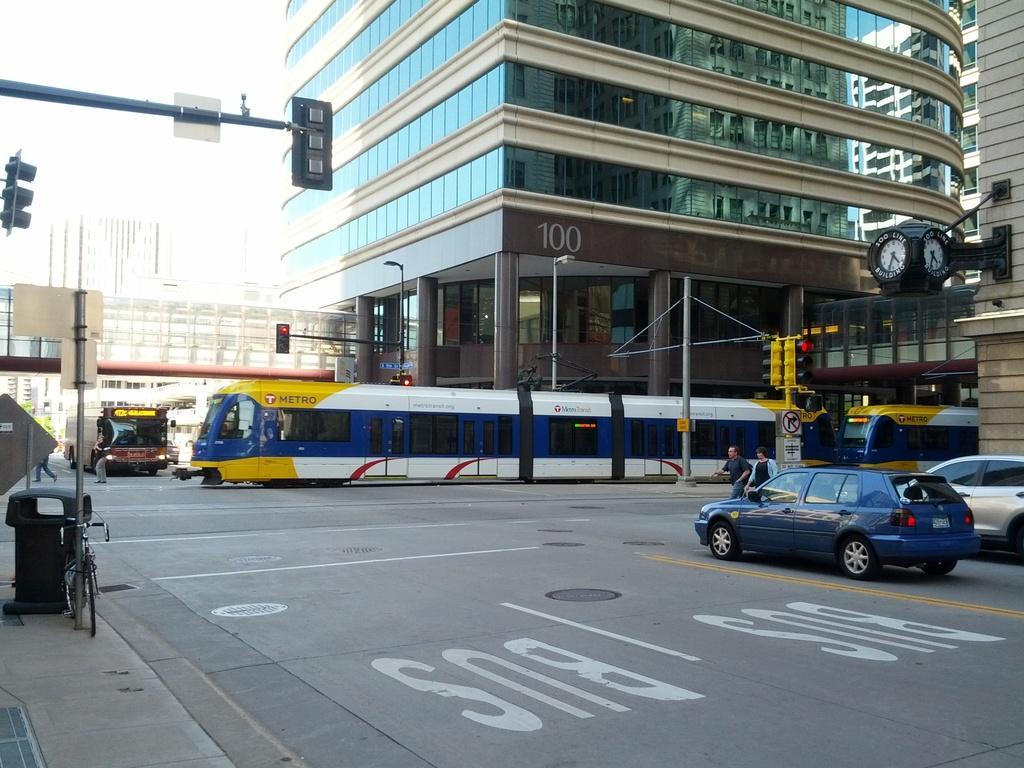Could you give a brief overview of what you see in this image? In this image, we can see few vehicles on the road. Here there are few buildings, traffic signals, poles, clocks, glass objects, walls, pillars and few things. In the middle of the image, we can see few people. 